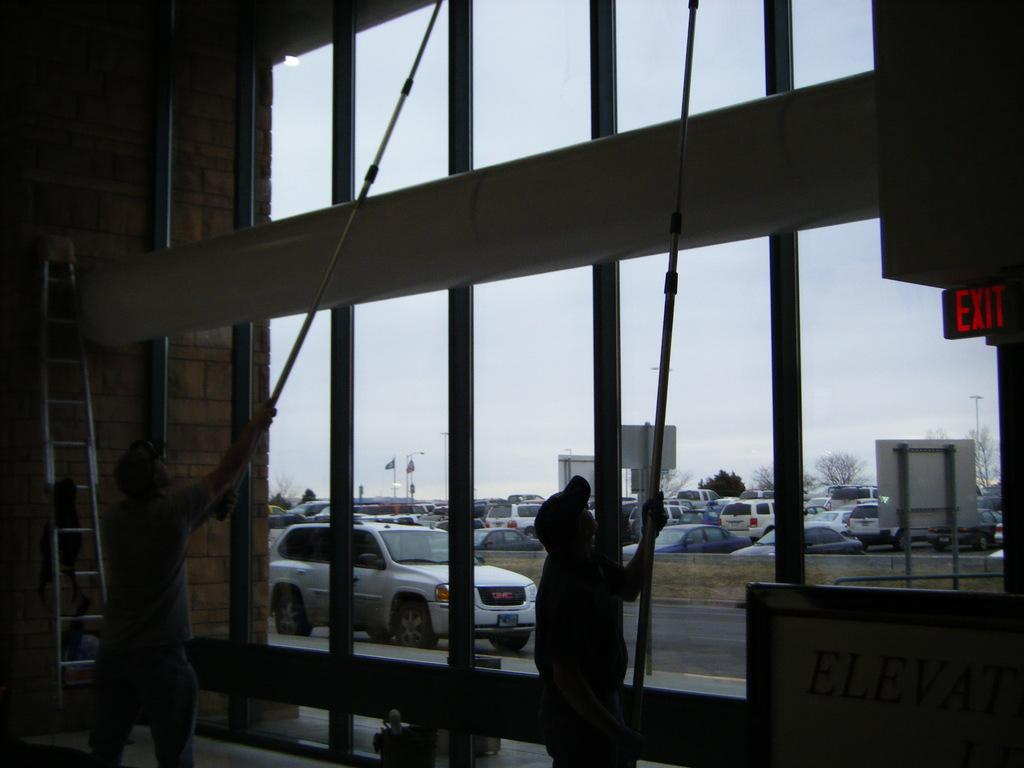What are the two people in the image doing? The two people in the image are cleaning the glass. What can be seen on the left side of the image? There is a ladder on the left side of the image. What is visible in the background of the image? Many cars are visible in the image. What type of volleyball game is being played in the image? There is no volleyball game present in the image. Can you tell me how many quivers are visible in the image? There are no quivers present in the image. 